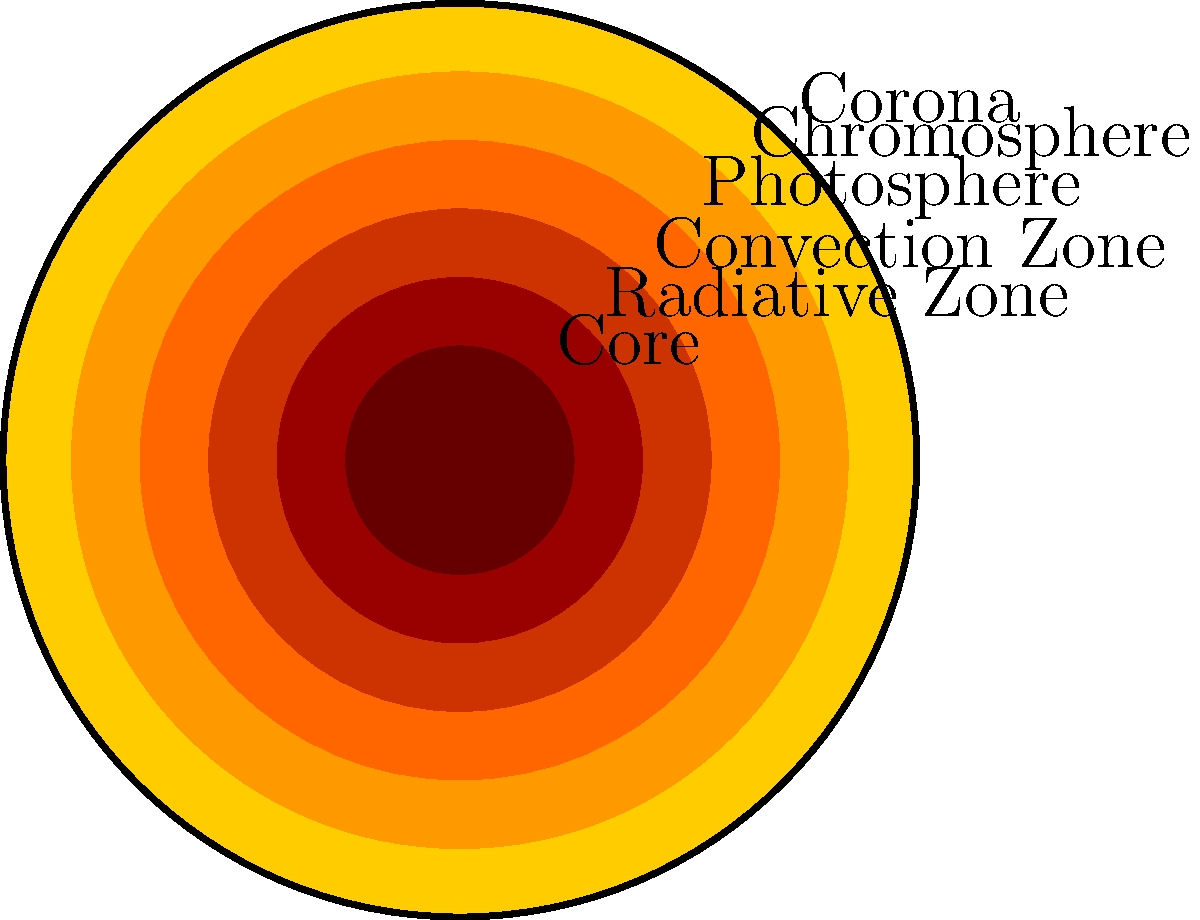As someone familiar with complex systems, which layer of the Sun is responsible for the energy generation through nuclear fusion? To answer this question, let's examine the layers of the Sun from the inside out:

1. Core: This is the innermost layer of the Sun, where temperatures reach about 15 million degrees Celsius. It's here that nuclear fusion occurs, converting hydrogen into helium and releasing enormous amounts of energy.

2. Radiative Zone: This layer surrounds the core. Energy from the core travels through this region via radiation.

3. Convection Zone: Above the radiative zone, energy is transferred by convection currents.

4. Photosphere: This is the visible surface of the Sun.

5. Chromosphere: A thin layer above the photosphere, visible during solar eclipses.

6. Corona: The outermost layer of the Sun's atmosphere, extending far into space.

The energy generation through nuclear fusion occurs in the core of the Sun. This is because:

1. The core has the highest temperature and pressure, necessary for nuclear fusion.
2. It contains the densest concentration of hydrogen atoms, the fuel for fusion.
3. The fusion process requires extreme conditions only found in the core.

The energy generated in the core then travels outward through the other layers before being emitted into space.
Answer: Core 